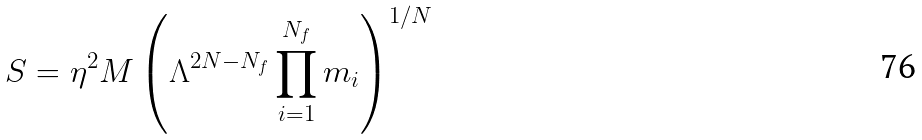<formula> <loc_0><loc_0><loc_500><loc_500>S = \eta ^ { 2 } M \left ( \Lambda ^ { 2 N - N _ { f } } \prod _ { i = 1 } ^ { N _ { f } } m _ { i } \right ) ^ { 1 / N }</formula> 